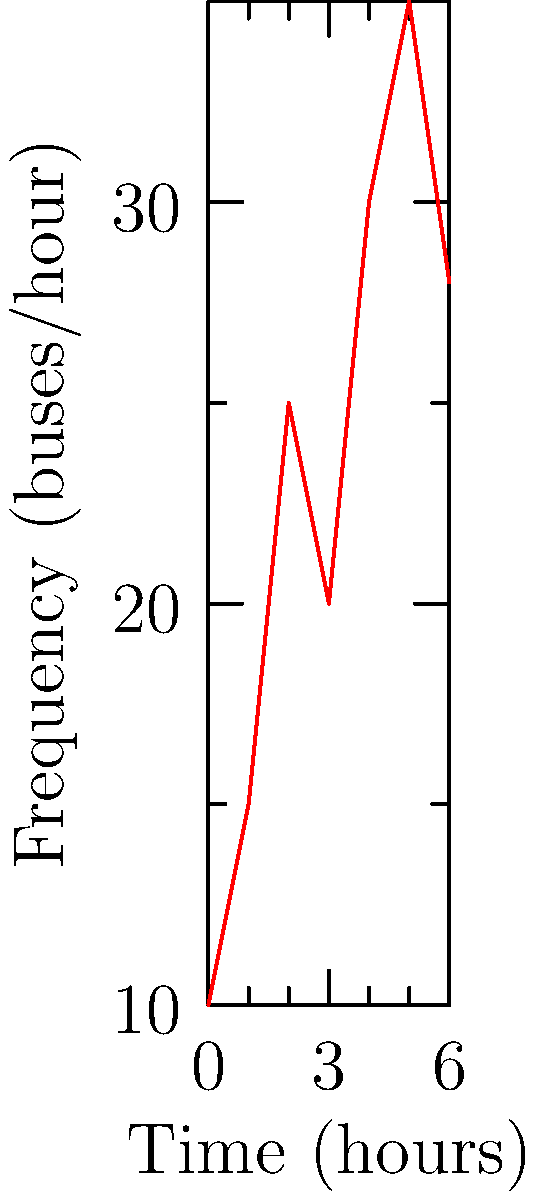Based on the line chart showing the frequency of public transport routes over time, what is the difference between the highest and lowest frequency of buses per hour? To find the difference between the highest and lowest frequency of buses per hour, we need to:

1. Identify the highest point on the graph:
   The highest point is at 5 hours, with a frequency of 35 buses/hour.

2. Identify the lowest point on the graph:
   The lowest point is at 0 hours (start of the day), with a frequency of 10 buses/hour.

3. Calculate the difference:
   $35 - 10 = 25$ buses/hour

This difference represents the range of bus frequency throughout the day, showing how much the service increases from its lowest to highest point to accommodate varying demand.
Answer: 25 buses/hour 